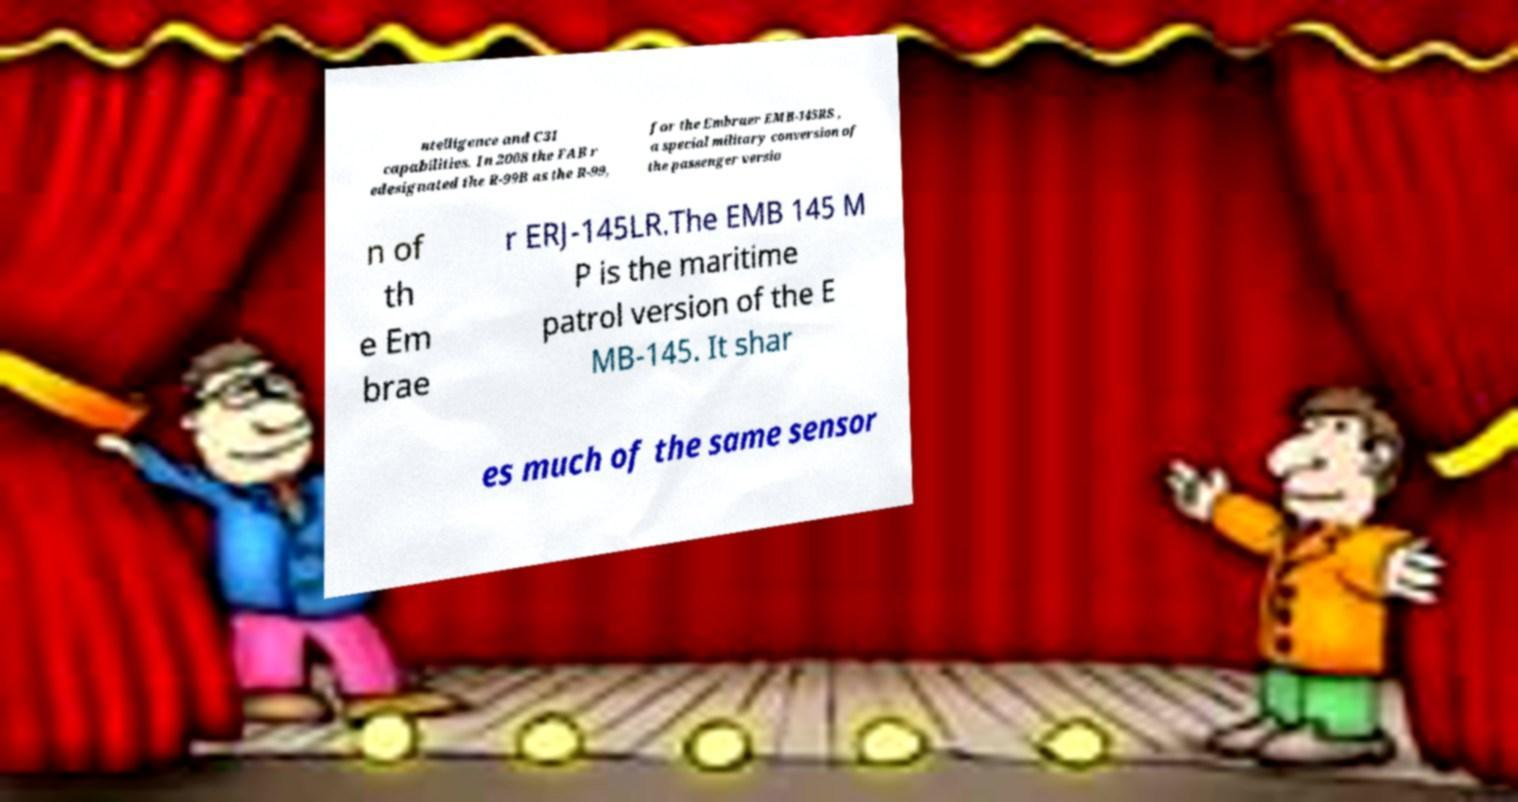Could you extract and type out the text from this image? ntelligence and C3I capabilities. In 2008 the FAB r edesignated the R-99B as the R-99, for the Embraer EMB-145RS , a special military conversion of the passenger versio n of th e Em brae r ERJ-145LR.The EMB 145 M P is the maritime patrol version of the E MB-145. It shar es much of the same sensor 